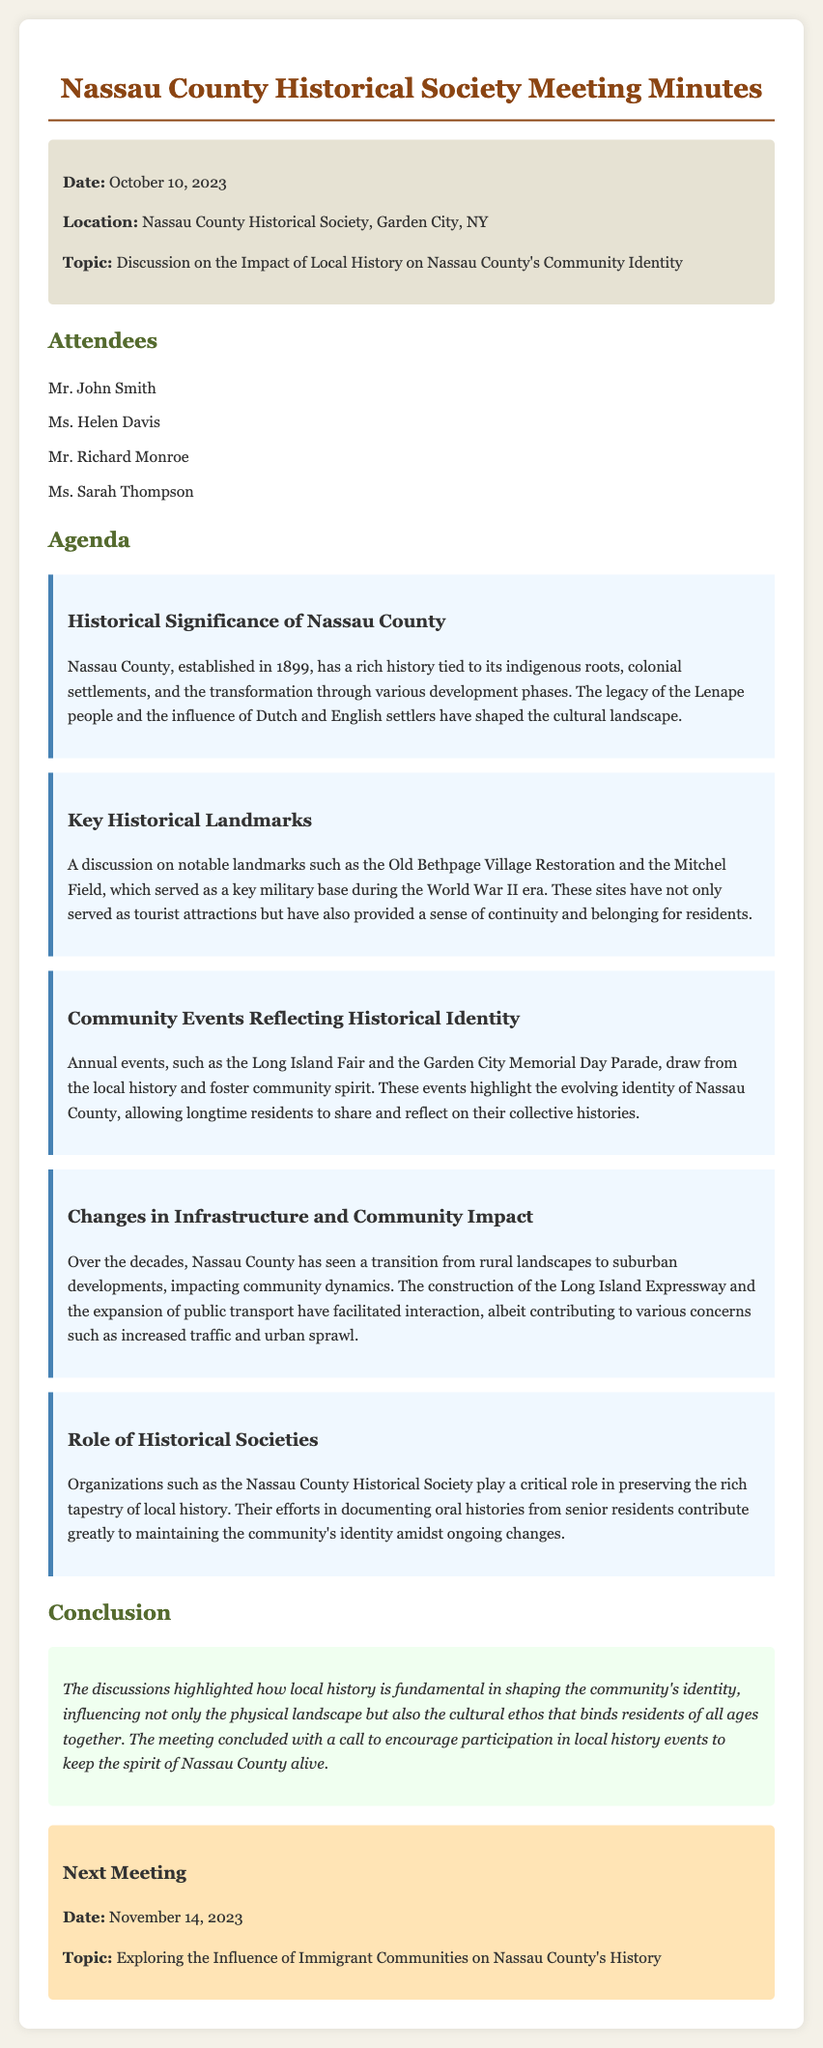What is the date of the meeting? The meeting is dated October 10, 2023, as stated in the document.
Answer: October 10, 2023 Where was the meeting held? The location of the meeting is mentioned as Nassau County Historical Society, Garden City, NY.
Answer: Nassau County Historical Society, Garden City, NY Who are the attendees listed in the meeting minutes? The names of the attendees are specifically noted in the document.
Answer: Mr. John Smith, Ms. Helen Davis, Mr. Richard Monroe, Ms. Sarah Thompson What is one key historical landmark mentioned? The document discusses specific landmarks; one is mentioned directly.
Answer: Old Bethpage Village Restoration What community event is highlighted in the minutes? The minutes refer to community events that are significant for the local identity.
Answer: Long Island Fair How has Nassau County's infrastructure changed over time? Changes in infrastructure are discussed regarding their impact on community dynamics.
Answer: Transition from rural landscapes to suburban developments What role do historical societies play according to the document? The impact of historical societies is summarized in the text.
Answer: Preserving local history What is the topic of the next meeting? The next meeting's topic is introduced toward the end of the document.
Answer: Exploring the Influence of Immigrant Communities on Nassau County's History What is stated about the importance of local history? The conclusion section highlights the significance of local history.
Answer: Fundamental in shaping community identity 